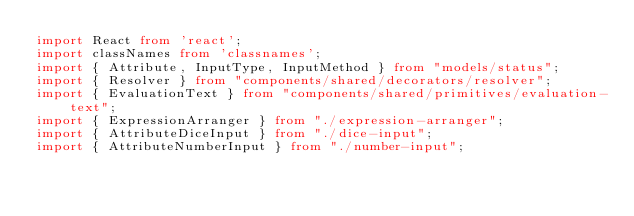Convert code to text. <code><loc_0><loc_0><loc_500><loc_500><_TypeScript_>import React from 'react';
import classNames from 'classnames';
import { Attribute, InputType, InputMethod } from "models/status";
import { Resolver } from "components/shared/decorators/resolver";
import { EvaluationText } from "components/shared/primitives/evaluation-text";
import { ExpressionArranger } from "./expression-arranger";
import { AttributeDiceInput } from "./dice-input";
import { AttributeNumberInput } from "./number-input";</code> 